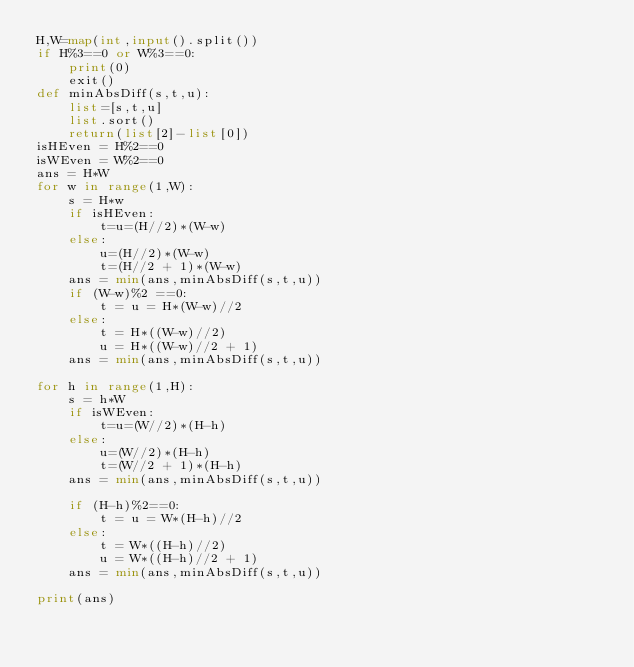Convert code to text. <code><loc_0><loc_0><loc_500><loc_500><_Python_>H,W=map(int,input().split())
if H%3==0 or W%3==0:
    print(0)
    exit()
def minAbsDiff(s,t,u):
    list=[s,t,u]
    list.sort()
    return(list[2]-list[0])
isHEven = H%2==0
isWEven = W%2==0
ans = H*W
for w in range(1,W):
    s = H*w
    if isHEven:
        t=u=(H//2)*(W-w)
    else:
        u=(H//2)*(W-w)
        t=(H//2 + 1)*(W-w)
    ans = min(ans,minAbsDiff(s,t,u))
    if (W-w)%2 ==0:
        t = u = H*(W-w)//2
    else:
        t = H*((W-w)//2)
        u = H*((W-w)//2 + 1)
    ans = min(ans,minAbsDiff(s,t,u))

for h in range(1,H):
    s = h*W
    if isWEven:
        t=u=(W//2)*(H-h)
    else:
        u=(W//2)*(H-h)
        t=(W//2 + 1)*(H-h)
    ans = min(ans,minAbsDiff(s,t,u))

    if (H-h)%2==0:
        t = u = W*(H-h)//2
    else:
        t = W*((H-h)//2)
        u = W*((H-h)//2 + 1)
    ans = min(ans,minAbsDiff(s,t,u))

print(ans)</code> 